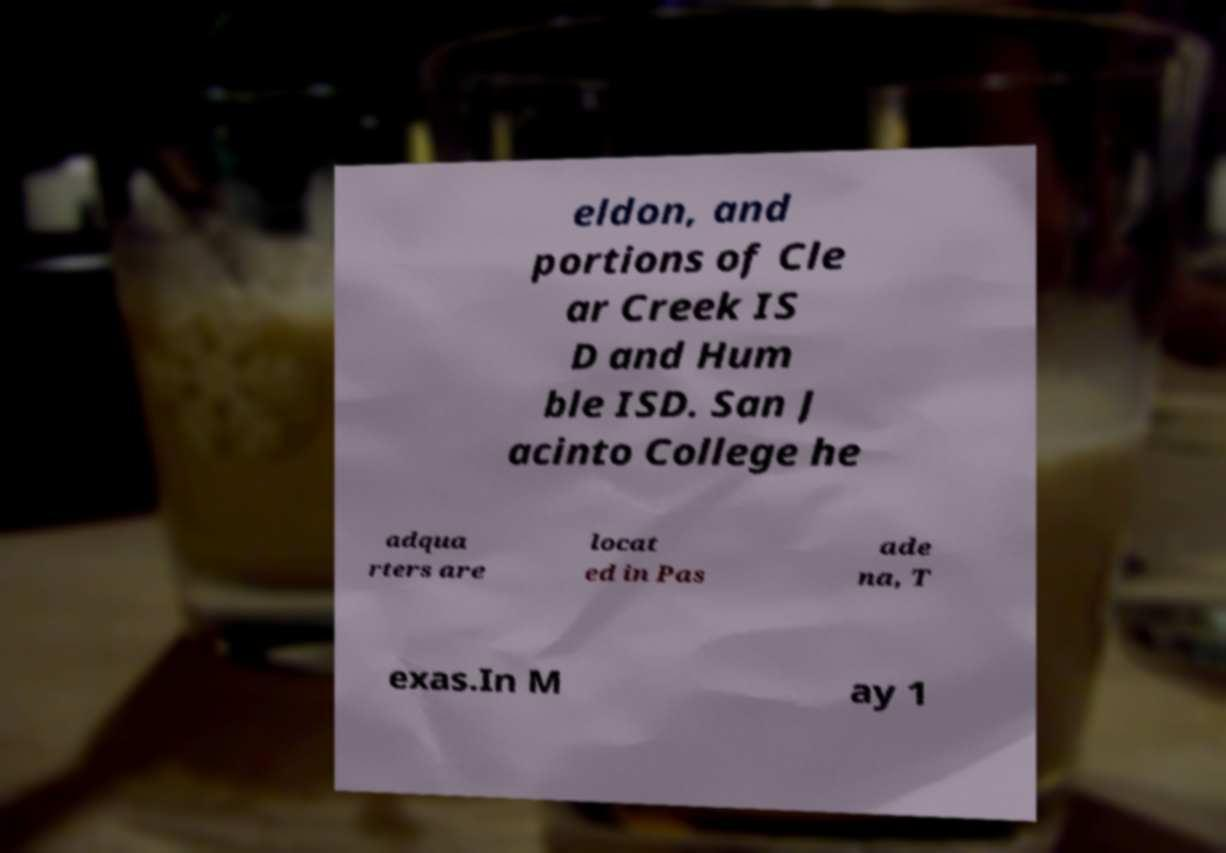For documentation purposes, I need the text within this image transcribed. Could you provide that? eldon, and portions of Cle ar Creek IS D and Hum ble ISD. San J acinto College he adqua rters are locat ed in Pas ade na, T exas.In M ay 1 